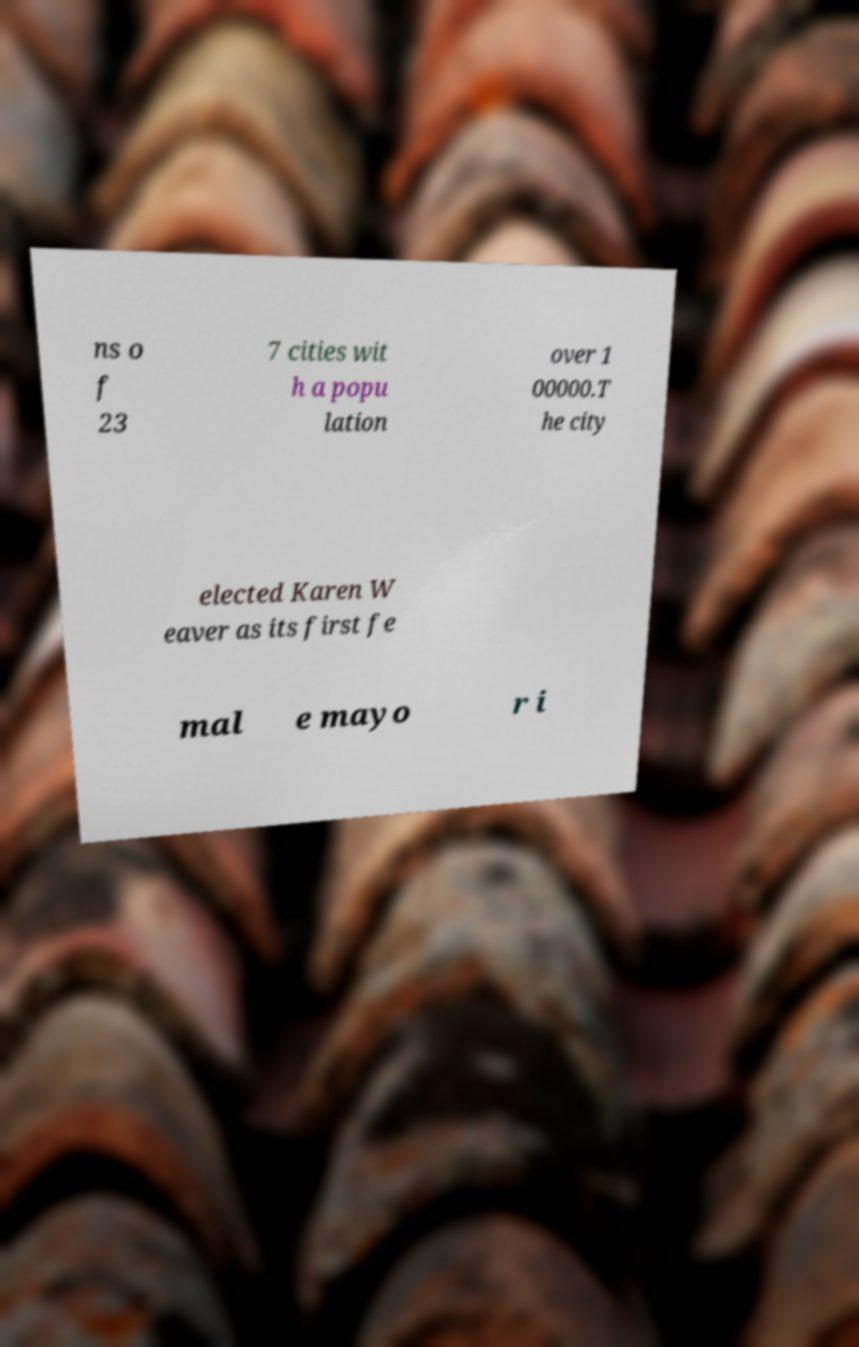Could you extract and type out the text from this image? ns o f 23 7 cities wit h a popu lation over 1 00000.T he city elected Karen W eaver as its first fe mal e mayo r i 